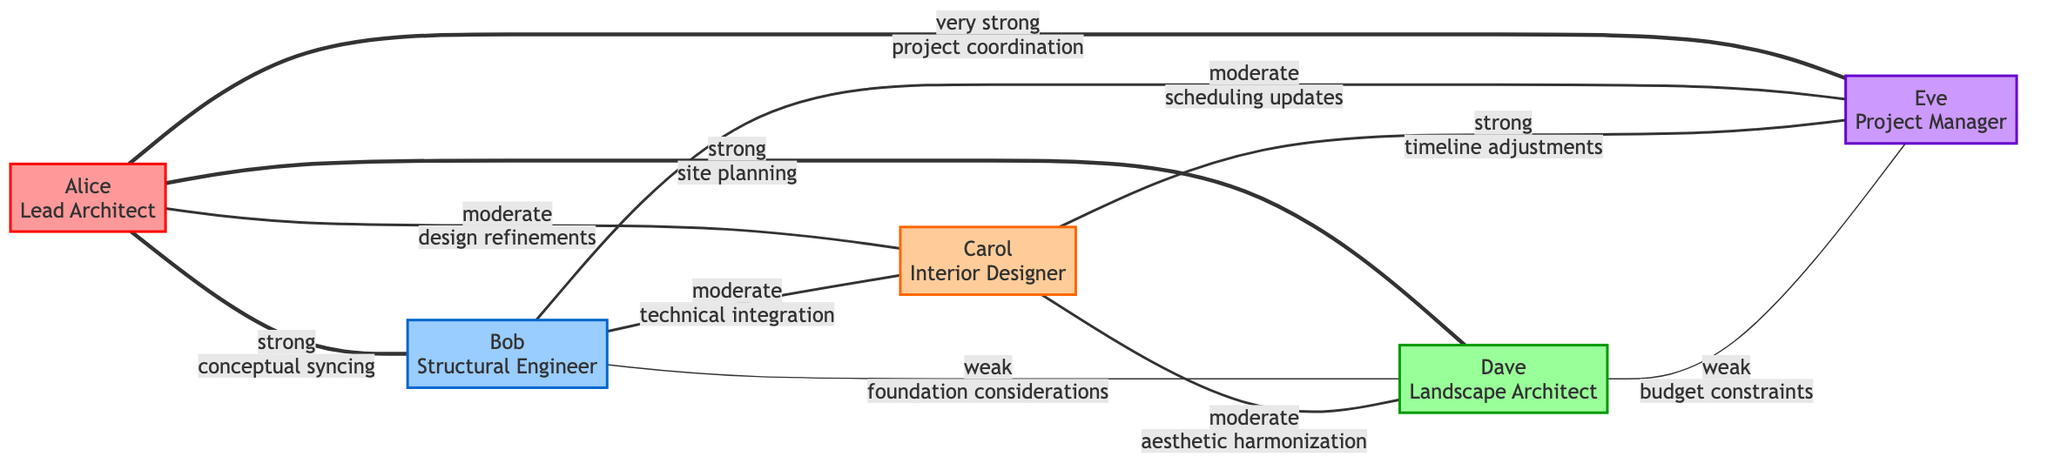What is the role of Alice? The diagram indicates that Alice's role is labeled as the "Lead Architect."
Answer: Lead Architect How many nodes are in the graph? By counting the entries in the nodes section of the data, we see there are five individuals represented, thus five nodes total.
Answer: 5 What type of collaboration style does Bob have? Referring to Bob's attributes in the nodes section, his collaboration style is specified as "supportive."
Answer: supportive How many edges connect Carol to other team members? By examining the edges for connections to Carol, we find three edges, linking her to Bob, Dave, and Eve.
Answer: 3 What is the weight of the interaction between Alice and Eve? Looking at the edge connecting Alice and Eve, the weight of their interaction is labeled as "very strong."
Answer: very strong Which team member has a weak interaction with Eve? Upon reviewing the interactions, we note that Dave's interaction with Eve is labeled as "weak."
Answer: Dave What is the primary interaction type between Alice and Dave? From the edges section, it's evident that Alice and Dave's interaction is focused on "site planning."
Answer: site planning Which team member has the highest reported experience? By comparing the experience levels listed for each node, we determine that Alice has "extensive" experience, which is the highest.
Answer: extensive What is the relationship between Bob and Carol? The edge between Bob and Carol indicates their interaction is characterized as "moderate" with a focus on "technical integration."
Answer: moderate How many strong interactions does Alice have? Evaluating the edges connected to Alice, there are three strong interactions, with Bob, Dave, and Eve listed as strong connections.
Answer: 3 